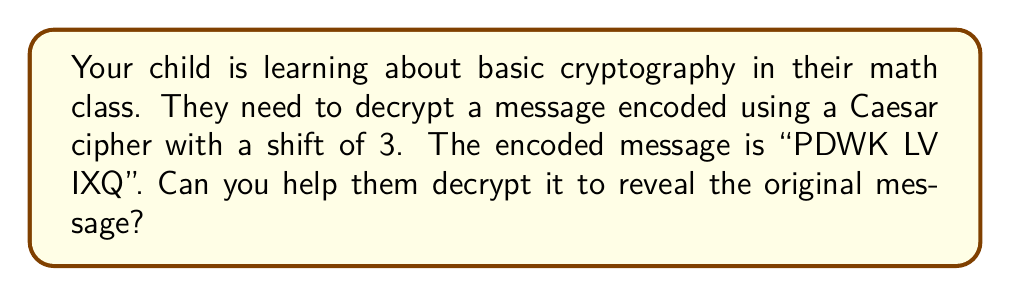Provide a solution to this math problem. To decrypt a Caesar cipher with a shift of 3, we need to shift each letter back by 3 positions in the alphabet. Here's how to do it step-by-step:

1) First, let's set up our alphabet with corresponding numbers:
   A B C D E F G H I J K L M N O P Q R S T U V W X Y Z
   0 1 2 3 4 5 6 7 8 9 10 11 12 13 14 15 16 17 18 19 20 21 22 23 24 25

2) For each letter in the encoded message, we'll subtract 3 from its number. If the result is negative, we add 26 to wrap around to the end of the alphabet.

3) Let's decrypt each letter:
   P (15) → M (12): 15 - 3 = 12
   D (3) → A (0): 3 - 3 = 0
   W (22) → T (19): 22 - 3 = 19
   K (10) → H (7): 10 - 3 = 7
   
   L (11) → I (8): 11 - 3 = 8
   V (21) → S (18): 21 - 3 = 18
   
   I (8) → F (5): 8 - 3 = 5
   X (23) → U (20): 23 - 3 = 20
   Q (16) → N (13): 16 - 3 = 13

4) Putting these decrypted letters together, we get: MATH IS FUN

Therefore, the original message before encryption was "MATH IS FUN".
Answer: MATH IS FUN 